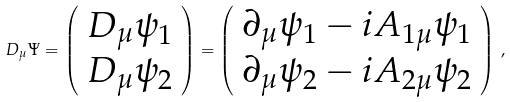Convert formula to latex. <formula><loc_0><loc_0><loc_500><loc_500>\ D _ { \mu } \Psi = \left ( \begin{array} { c } D _ { \mu } \psi _ { 1 } \\ D _ { \mu } \psi _ { 2 } \end{array} \right ) = \left ( \begin{array} { c } \partial _ { \mu } \psi _ { 1 } - i A _ { 1 \mu } \psi _ { 1 } \\ \partial _ { \mu } \psi _ { 2 } - i A _ { 2 \mu } \psi _ { 2 } \end{array} \right ) \, ,</formula> 